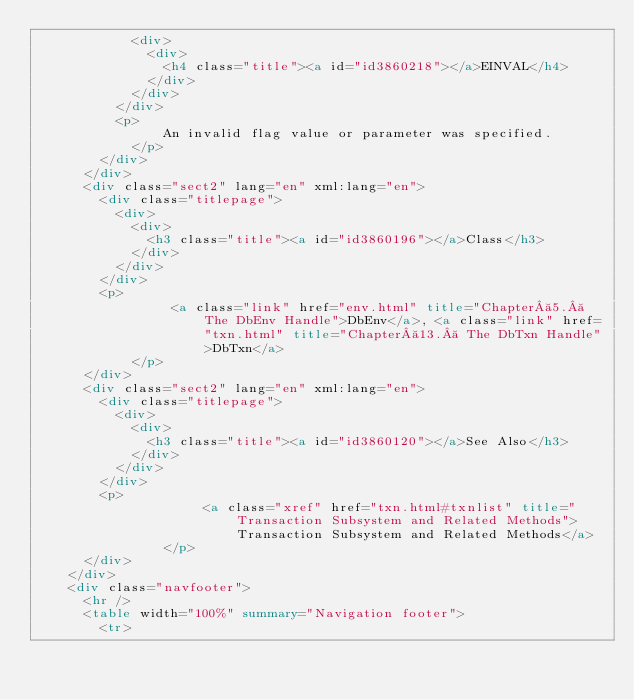<code> <loc_0><loc_0><loc_500><loc_500><_HTML_>            <div>
              <div>
                <h4 class="title"><a id="id3860218"></a>EINVAL</h4>
              </div>
            </div>
          </div>
          <p>
                An invalid flag value or parameter was specified.
            </p>
        </div>
      </div>
      <div class="sect2" lang="en" xml:lang="en">
        <div class="titlepage">
          <div>
            <div>
              <h3 class="title"><a id="id3860196"></a>Class</h3>
            </div>
          </div>
        </div>
        <p>
                 <a class="link" href="env.html" title="Chapter 5.  The DbEnv Handle">DbEnv</a>, <a class="link" href="txn.html" title="Chapter 13.  The DbTxn Handle">DbTxn</a> 
            </p>
      </div>
      <div class="sect2" lang="en" xml:lang="en">
        <div class="titlepage">
          <div>
            <div>
              <h3 class="title"><a id="id3860120"></a>See Also</h3>
            </div>
          </div>
        </div>
        <p>
                     <a class="xref" href="txn.html#txnlist" title="Transaction Subsystem and Related Methods">Transaction Subsystem and Related Methods</a> 
                </p>
      </div>
    </div>
    <div class="navfooter">
      <hr />
      <table width="100%" summary="Navigation footer">
        <tr></code> 